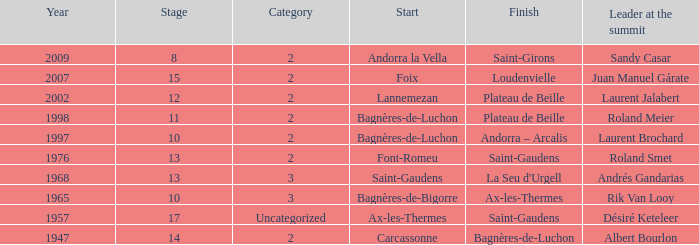Name the start of an event in Catagory 2 of the year 1947. Carcassonne. 